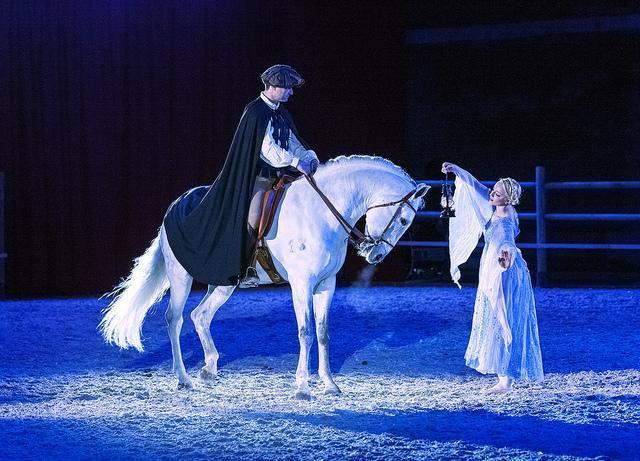How many people are there?
Give a very brief answer. 2. 